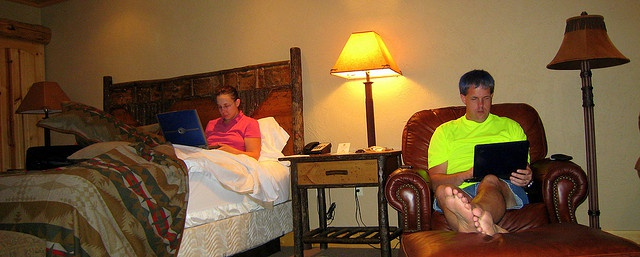Describe the objects in this image and their specific colors. I can see bed in black, maroon, olive, and gray tones, couch in black, maroon, and brown tones, chair in black, maroon, olive, and gray tones, people in black, lime, brown, and maroon tones, and people in black, red, brown, and maroon tones in this image. 